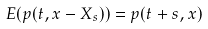Convert formula to latex. <formula><loc_0><loc_0><loc_500><loc_500>E ( p ( t , x - X _ { s } ) ) = p ( t + s , x )</formula> 